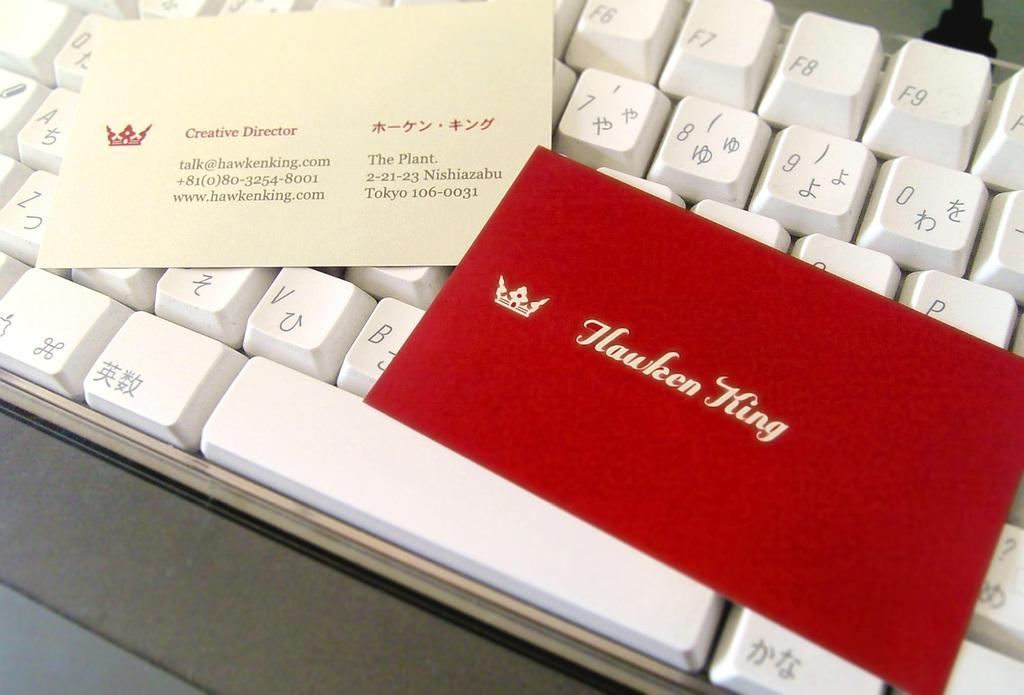Provide a one-sentence caption for the provided image. A business card for the creative director sits on a keyboard. 